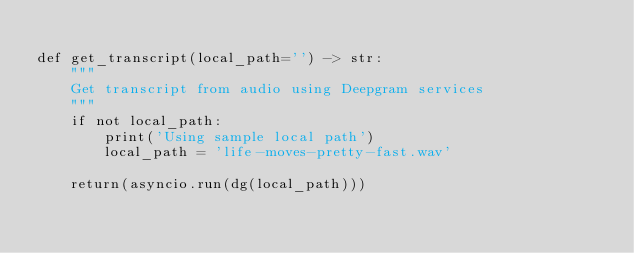Convert code to text. <code><loc_0><loc_0><loc_500><loc_500><_Python_>
def get_transcript(local_path='') -> str:
    """
    Get transcript from audio using Deepgram services
    """
    if not local_path:
        print('Using sample local path')
        local_path = 'life-moves-pretty-fast.wav'

    return(asyncio.run(dg(local_path)))
</code> 